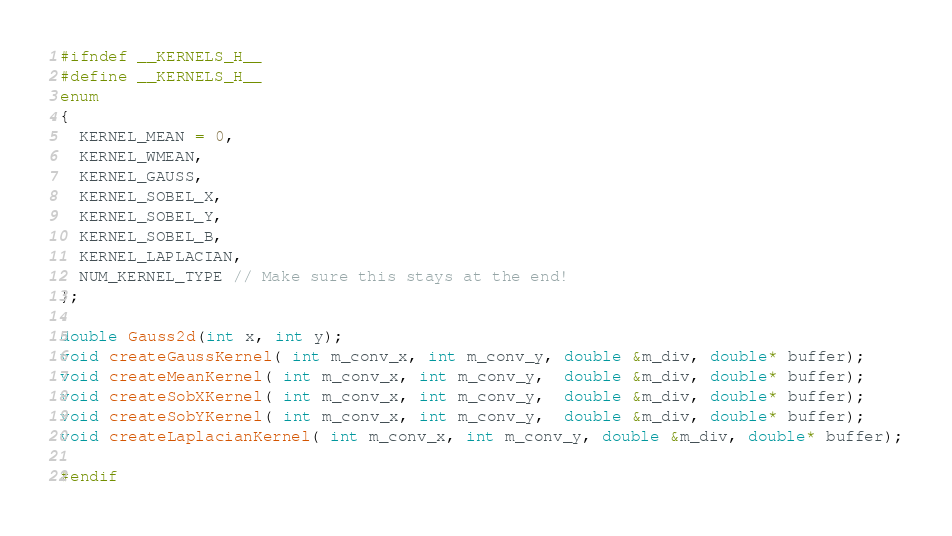<code> <loc_0><loc_0><loc_500><loc_500><_C_>#ifndef __KERNELS_H__
#define __KERNELS_H__
enum
{
  KERNEL_MEAN = 0,
  KERNEL_WMEAN,
  KERNEL_GAUSS,
  KERNEL_SOBEL_X,
  KERNEL_SOBEL_Y,
  KERNEL_SOBEL_B,
  KERNEL_LAPLACIAN,
  NUM_KERNEL_TYPE // Make sure this stays at the end!
};

double Gauss2d(int x, int y);
void createGaussKernel( int m_conv_x, int m_conv_y, double &m_div, double* buffer);
void createMeanKernel( int m_conv_x, int m_conv_y,  double &m_div, double* buffer);
void createSobXKernel( int m_conv_x, int m_conv_y,  double &m_div, double* buffer);
void createSobYKernel( int m_conv_x, int m_conv_y,  double &m_div, double* buffer);
void createLaplacianKernel( int m_conv_x, int m_conv_y, double &m_div, double* buffer);

#endif
</code> 